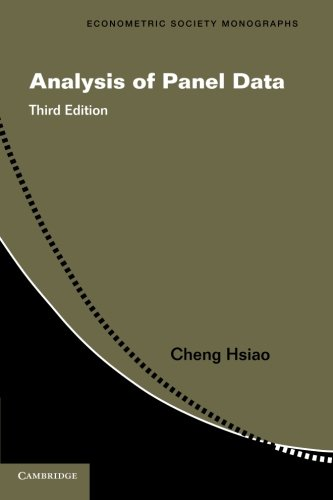What is the title of this book? The title of this book is 'Analysis of Panel Data,' which is part of the Econometric Society Monographs series. This third edition delves into statistical methods used in analysing panel data. 